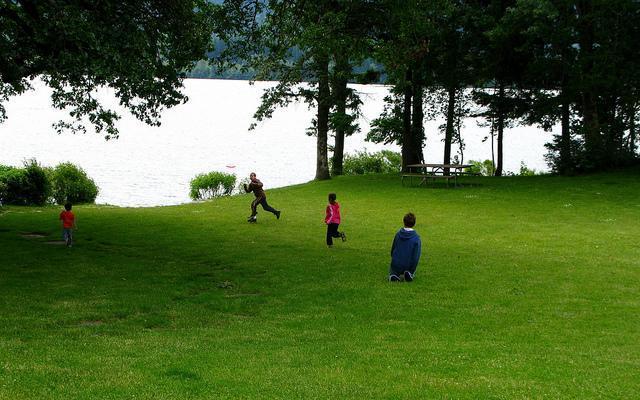How many kids are there?
Give a very brief answer. 4. How many people are in the picture?
Give a very brief answer. 4. How many sinks are there?
Give a very brief answer. 0. 